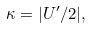<formula> <loc_0><loc_0><loc_500><loc_500>\kappa = | U ^ { \prime } / 2 | ,</formula> 